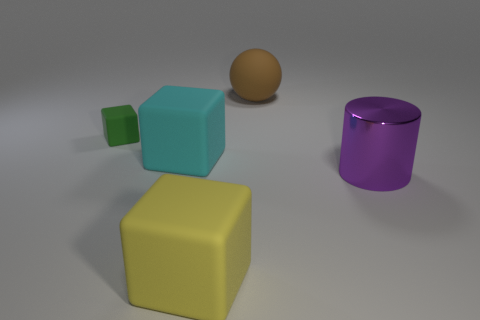Subtract all large blocks. How many blocks are left? 1 Add 3 small matte things. How many objects exist? 8 Subtract all blocks. How many objects are left? 2 Subtract all cyan blocks. How many yellow cylinders are left? 0 Subtract all big matte balls. Subtract all cyan objects. How many objects are left? 3 Add 4 large yellow rubber objects. How many large yellow rubber objects are left? 5 Add 4 yellow things. How many yellow things exist? 5 Subtract 0 red cylinders. How many objects are left? 5 Subtract all gray cubes. Subtract all green balls. How many cubes are left? 3 